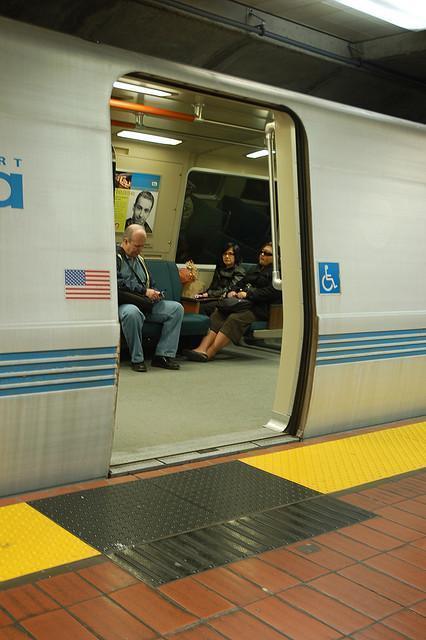What has the train indicated it is accessible to?
Choose the right answer from the provided options to respond to the question.
Options: Planes, cars, bikes, wheelchairs. Wheelchairs. 